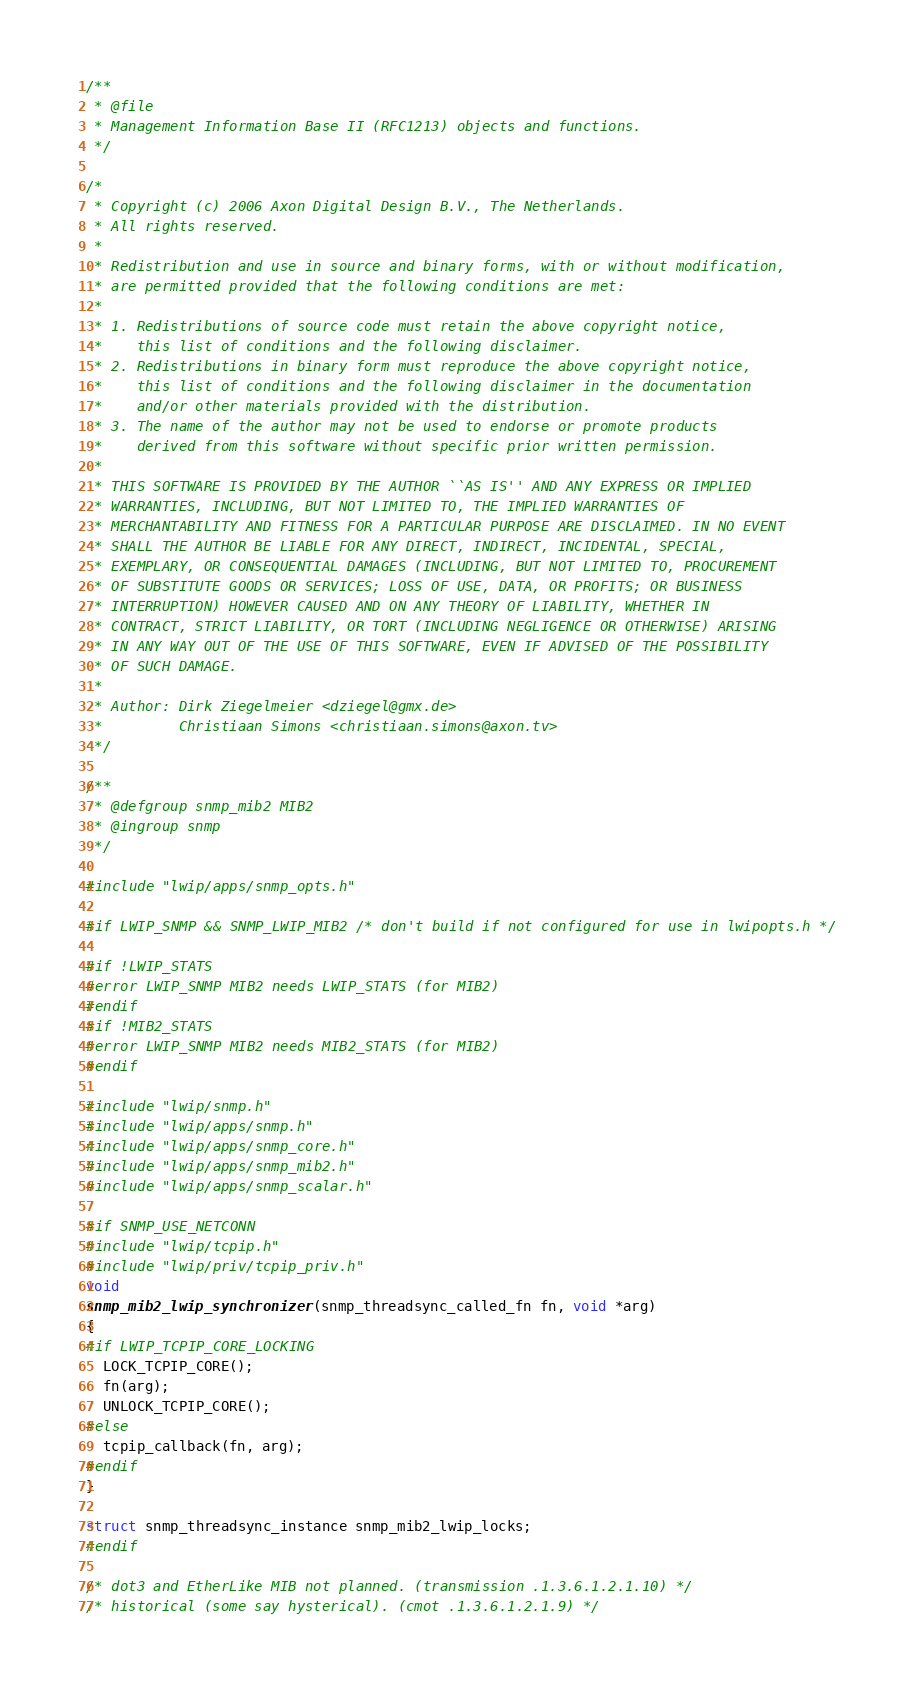Convert code to text. <code><loc_0><loc_0><loc_500><loc_500><_C_>/**
 * @file
 * Management Information Base II (RFC1213) objects and functions.
 */

/*
 * Copyright (c) 2006 Axon Digital Design B.V., The Netherlands.
 * All rights reserved.
 *
 * Redistribution and use in source and binary forms, with or without modification,
 * are permitted provided that the following conditions are met:
 *
 * 1. Redistributions of source code must retain the above copyright notice,
 *    this list of conditions and the following disclaimer.
 * 2. Redistributions in binary form must reproduce the above copyright notice,
 *    this list of conditions and the following disclaimer in the documentation
 *    and/or other materials provided with the distribution.
 * 3. The name of the author may not be used to endorse or promote products
 *    derived from this software without specific prior written permission.
 *
 * THIS SOFTWARE IS PROVIDED BY THE AUTHOR ``AS IS'' AND ANY EXPRESS OR IMPLIED
 * WARRANTIES, INCLUDING, BUT NOT LIMITED TO, THE IMPLIED WARRANTIES OF
 * MERCHANTABILITY AND FITNESS FOR A PARTICULAR PURPOSE ARE DISCLAIMED. IN NO EVENT
 * SHALL THE AUTHOR BE LIABLE FOR ANY DIRECT, INDIRECT, INCIDENTAL, SPECIAL,
 * EXEMPLARY, OR CONSEQUENTIAL DAMAGES (INCLUDING, BUT NOT LIMITED TO, PROCUREMENT
 * OF SUBSTITUTE GOODS OR SERVICES; LOSS OF USE, DATA, OR PROFITS; OR BUSINESS
 * INTERRUPTION) HOWEVER CAUSED AND ON ANY THEORY OF LIABILITY, WHETHER IN
 * CONTRACT, STRICT LIABILITY, OR TORT (INCLUDING NEGLIGENCE OR OTHERWISE) ARISING
 * IN ANY WAY OUT OF THE USE OF THIS SOFTWARE, EVEN IF ADVISED OF THE POSSIBILITY
 * OF SUCH DAMAGE.
 *
 * Author: Dirk Ziegelmeier <dziegel@gmx.de>
 *         Christiaan Simons <christiaan.simons@axon.tv>
 */

/**
 * @defgroup snmp_mib2 MIB2
 * @ingroup snmp
 */

#include "lwip/apps/snmp_opts.h"

#if LWIP_SNMP && SNMP_LWIP_MIB2 /* don't build if not configured for use in lwipopts.h */

#if !LWIP_STATS
#error LWIP_SNMP MIB2 needs LWIP_STATS (for MIB2)
#endif
#if !MIB2_STATS
#error LWIP_SNMP MIB2 needs MIB2_STATS (for MIB2)
#endif

#include "lwip/snmp.h"
#include "lwip/apps/snmp.h"
#include "lwip/apps/snmp_core.h"
#include "lwip/apps/snmp_mib2.h"
#include "lwip/apps/snmp_scalar.h"

#if SNMP_USE_NETCONN
#include "lwip/tcpip.h"
#include "lwip/priv/tcpip_priv.h"
void
snmp_mib2_lwip_synchronizer(snmp_threadsync_called_fn fn, void *arg)
{
#if LWIP_TCPIP_CORE_LOCKING
  LOCK_TCPIP_CORE();
  fn(arg);
  UNLOCK_TCPIP_CORE();
#else
  tcpip_callback(fn, arg);
#endif
}

struct snmp_threadsync_instance snmp_mib2_lwip_locks;
#endif

/* dot3 and EtherLike MIB not planned. (transmission .1.3.6.1.2.1.10) */
/* historical (some say hysterical). (cmot .1.3.6.1.2.1.9) */</code> 